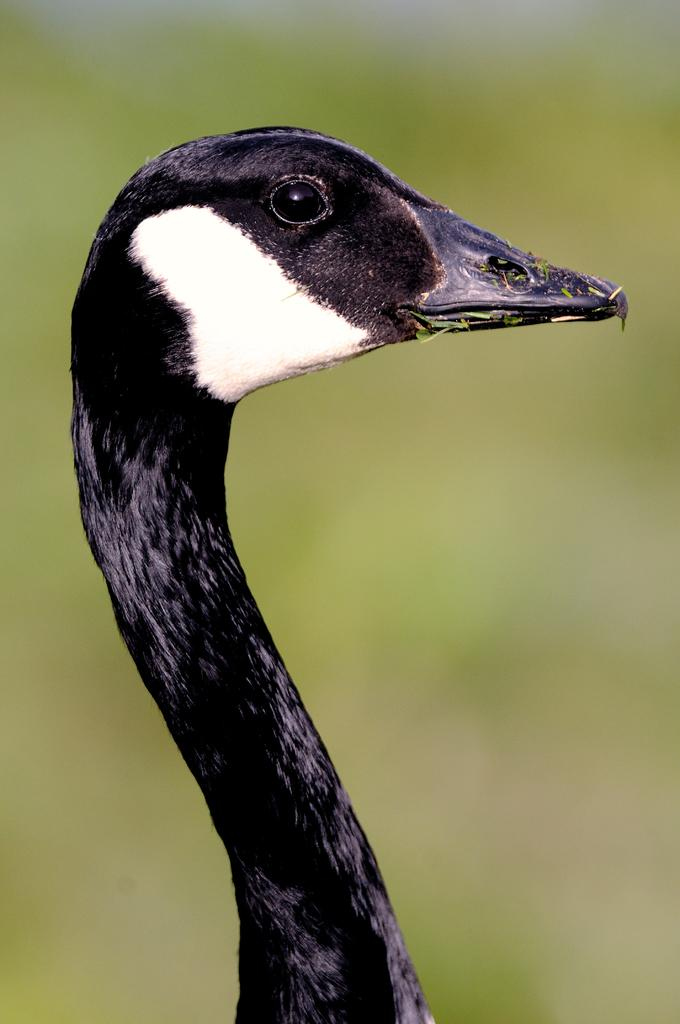What type of animal is in the image? There is a bird in the image. Can you describe the coloring of the bird? The bird has white and black coloring. What can be seen in the background of the image? The background of the image is green. What type of sponge is being exchanged between the birds in the image? There are no sponges or exchanges between birds in the image; it only features a single bird with white and black coloring against a green background. 